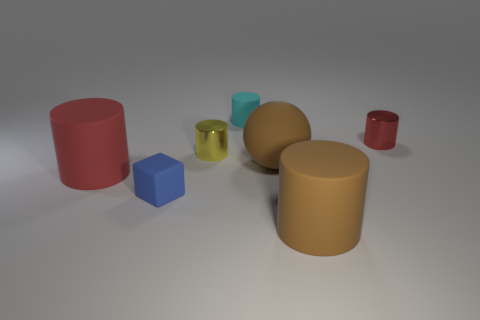The thing that is the same color as the matte ball is what shape? cylinder 